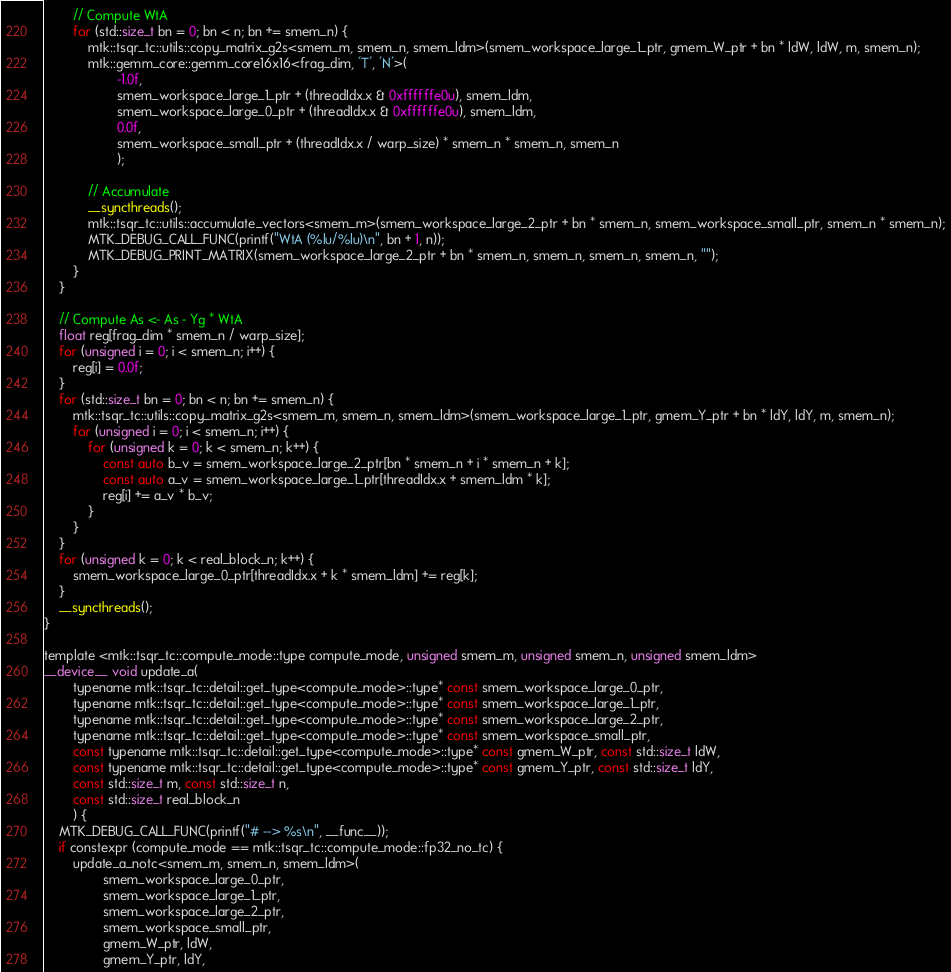Convert code to text. <code><loc_0><loc_0><loc_500><loc_500><_Cuda_>		// Compute WtA
		for (std::size_t bn = 0; bn < n; bn += smem_n) {
			mtk::tsqr_tc::utils::copy_matrix_g2s<smem_m, smem_n, smem_ldm>(smem_workspace_large_1_ptr, gmem_W_ptr + bn * ldW, ldW, m, smem_n);
			mtk::gemm_core::gemm_core16x16<frag_dim, 'T', 'N'>(
					-1.0f,
					smem_workspace_large_1_ptr + (threadIdx.x & 0xffffffe0u), smem_ldm,
					smem_workspace_large_0_ptr + (threadIdx.x & 0xffffffe0u), smem_ldm,
					0.0f,
					smem_workspace_small_ptr + (threadIdx.x / warp_size) * smem_n * smem_n, smem_n
					);

			// Accumulate
			__syncthreads();
			mtk::tsqr_tc::utils::accumulate_vectors<smem_m>(smem_workspace_large_2_ptr + bn * smem_n, smem_workspace_small_ptr, smem_n * smem_n);
			MTK_DEBUG_CALL_FUNC(printf("WtA (%lu/%lu)\n", bn + 1, n));
			MTK_DEBUG_PRINT_MATRIX(smem_workspace_large_2_ptr + bn * smem_n, smem_n, smem_n, smem_n, "");
		}
	}

	// Compute As <- As - Yg * WtA
	float reg[frag_dim * smem_n / warp_size];
	for (unsigned i = 0; i < smem_n; i++) {
		reg[i] = 0.0f;
	}
	for (std::size_t bn = 0; bn < n; bn += smem_n) {
		mtk::tsqr_tc::utils::copy_matrix_g2s<smem_m, smem_n, smem_ldm>(smem_workspace_large_1_ptr, gmem_Y_ptr + bn * ldY, ldY, m, smem_n);
		for (unsigned i = 0; i < smem_n; i++) {
			for (unsigned k = 0; k < smem_n; k++) {
				const auto b_v = smem_workspace_large_2_ptr[bn * smem_n + i * smem_n + k];
				const auto a_v = smem_workspace_large_1_ptr[threadIdx.x + smem_ldm * k];
				reg[i] += a_v * b_v;
			}
		}
	}
	for (unsigned k = 0; k < real_block_n; k++) {
		smem_workspace_large_0_ptr[threadIdx.x + k * smem_ldm] += reg[k];
	}
	__syncthreads();
}

template <mtk::tsqr_tc::compute_mode::type compute_mode, unsigned smem_m, unsigned smem_n, unsigned smem_ldm>
__device__ void update_a(
		typename mtk::tsqr_tc::detail::get_type<compute_mode>::type* const smem_workspace_large_0_ptr,
		typename mtk::tsqr_tc::detail::get_type<compute_mode>::type* const smem_workspace_large_1_ptr,
		typename mtk::tsqr_tc::detail::get_type<compute_mode>::type* const smem_workspace_large_2_ptr,
		typename mtk::tsqr_tc::detail::get_type<compute_mode>::type* const smem_workspace_small_ptr,
		const typename mtk::tsqr_tc::detail::get_type<compute_mode>::type* const gmem_W_ptr, const std::size_t ldW,
		const typename mtk::tsqr_tc::detail::get_type<compute_mode>::type* const gmem_Y_ptr, const std::size_t ldY,
		const std::size_t m, const std::size_t n,
		const std::size_t real_block_n
		) {
	MTK_DEBUG_CALL_FUNC(printf("# --> %s\n", __func__));
	if constexpr (compute_mode == mtk::tsqr_tc::compute_mode::fp32_no_tc) {
		update_a_notc<smem_m, smem_n, smem_ldm>(
				smem_workspace_large_0_ptr,
				smem_workspace_large_1_ptr,
				smem_workspace_large_2_ptr,
				smem_workspace_small_ptr,
				gmem_W_ptr, ldW,
				gmem_Y_ptr, ldY,</code> 